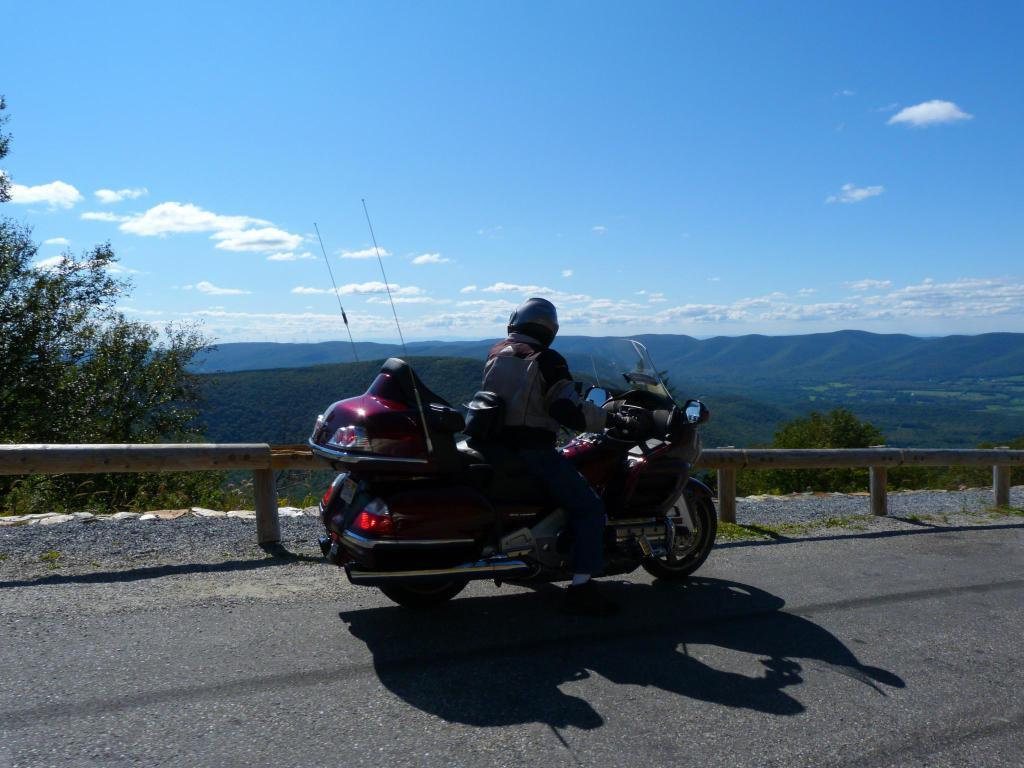What is the person in the image doing? There is a person riding a vehicle on the road in the image. What can be seen in the background of the image? There are trees and mountains visible in the background, as well as clouds in the sky. What type of scissors can be seen cutting the grass in the image? There are no scissors present in the image, as it features a person riding a vehicle on the road with trees, mountains, and clouds in the background. 